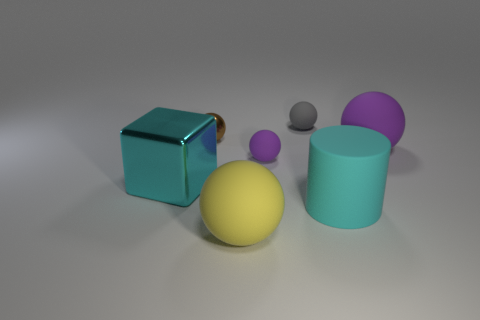There is a purple ball that is in front of the big matte sphere to the right of the gray matte thing; are there any yellow things that are on the left side of it?
Keep it short and to the point. Yes. Are there any purple matte objects behind the small purple thing?
Your response must be concise. Yes. How many large metallic blocks are the same color as the cylinder?
Your answer should be very brief. 1. The yellow thing that is made of the same material as the gray sphere is what size?
Your response must be concise. Large. There is a ball that is in front of the metallic thing in front of the tiny object left of the small purple rubber ball; how big is it?
Your response must be concise. Large. How big is the cyan object to the right of the big cube?
Provide a short and direct response. Large. How many purple objects are tiny matte balls or shiny balls?
Your answer should be compact. 1. Is there a yellow sphere that has the same size as the matte cylinder?
Keep it short and to the point. Yes. There is a purple thing that is the same size as the gray matte sphere; what is it made of?
Ensure brevity in your answer.  Rubber. Is the size of the ball that is left of the yellow rubber object the same as the purple matte sphere in front of the big purple rubber object?
Offer a very short reply. Yes. 